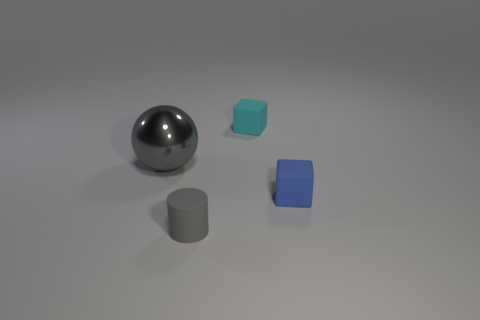Add 2 metal balls. How many objects exist? 6 Subtract all cylinders. How many objects are left? 3 Subtract all big gray shiny things. Subtract all cyan blocks. How many objects are left? 2 Add 1 large gray metallic spheres. How many large gray metallic spheres are left? 2 Add 4 small brown shiny cubes. How many small brown shiny cubes exist? 4 Subtract 0 purple cylinders. How many objects are left? 4 